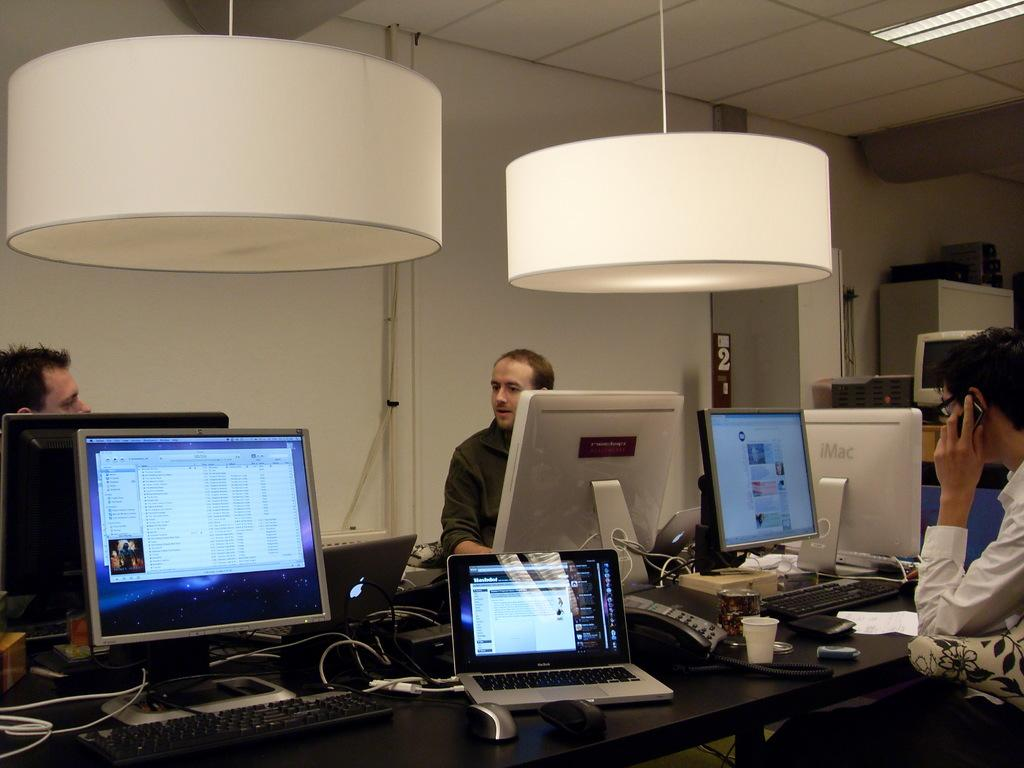What are the men in the image doing? The men in the image are sitting around a table and operating computers. Can you describe the lighting in the image? There is a chandelier hanging from the wall above the men, providing lighting. How many stars can be seen in the image? There are no stars visible in the image. 